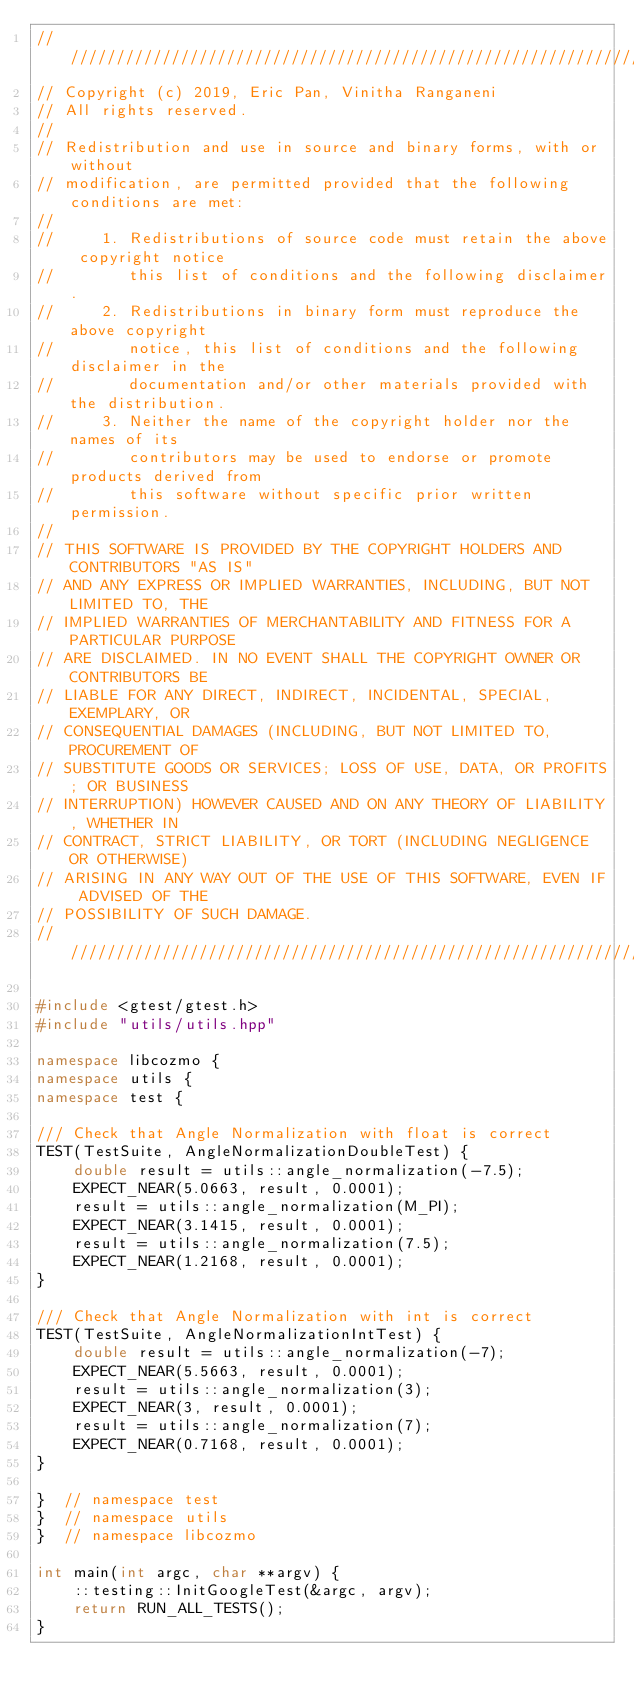Convert code to text. <code><loc_0><loc_0><loc_500><loc_500><_C++_>////////////////////////////////////////////////////////////////////////////////
// Copyright (c) 2019, Eric Pan, Vinitha Ranganeni
// All rights reserved.
//
// Redistribution and use in source and binary forms, with or without
// modification, are permitted provided that the following conditions are met:
//
//     1. Redistributions of source code must retain the above copyright notice
//        this list of conditions and the following disclaimer.
//     2. Redistributions in binary form must reproduce the above copyright
//        notice, this list of conditions and the following disclaimer in the
//        documentation and/or other materials provided with the distribution.
//     3. Neither the name of the copyright holder nor the names of its
//        contributors may be used to endorse or promote products derived from
//        this software without specific prior written permission.
//
// THIS SOFTWARE IS PROVIDED BY THE COPYRIGHT HOLDERS AND CONTRIBUTORS "AS IS"
// AND ANY EXPRESS OR IMPLIED WARRANTIES, INCLUDING, BUT NOT LIMITED TO, THE
// IMPLIED WARRANTIES OF MERCHANTABILITY AND FITNESS FOR A PARTICULAR PURPOSE
// ARE DISCLAIMED. IN NO EVENT SHALL THE COPYRIGHT OWNER OR CONTRIBUTORS BE
// LIABLE FOR ANY DIRECT, INDIRECT, INCIDENTAL, SPECIAL, EXEMPLARY, OR
// CONSEQUENTIAL DAMAGES (INCLUDING, BUT NOT LIMITED TO, PROCUREMENT OF
// SUBSTITUTE GOODS OR SERVICES; LOSS OF USE, DATA, OR PROFITS; OR BUSINESS
// INTERRUPTION) HOWEVER CAUSED AND ON ANY THEORY OF LIABILITY, WHETHER IN
// CONTRACT, STRICT LIABILITY, OR TORT (INCLUDING NEGLIGENCE OR OTHERWISE)
// ARISING IN ANY WAY OUT OF THE USE OF THIS SOFTWARE, EVEN IF ADVISED OF THE
// POSSIBILITY OF SUCH DAMAGE.
////////////////////////////////////////////////////////////////////////////////

#include <gtest/gtest.h>
#include "utils/utils.hpp"

namespace libcozmo {
namespace utils {
namespace test {

/// Check that Angle Normalization with float is correct
TEST(TestSuite, AngleNormalizationDoubleTest) {
    double result = utils::angle_normalization(-7.5);
    EXPECT_NEAR(5.0663, result, 0.0001);
    result = utils::angle_normalization(M_PI);
    EXPECT_NEAR(3.1415, result, 0.0001);
    result = utils::angle_normalization(7.5);
    EXPECT_NEAR(1.2168, result, 0.0001);
}

/// Check that Angle Normalization with int is correct
TEST(TestSuite, AngleNormalizationIntTest) {
    double result = utils::angle_normalization(-7);
    EXPECT_NEAR(5.5663, result, 0.0001);
    result = utils::angle_normalization(3);
    EXPECT_NEAR(3, result, 0.0001);
    result = utils::angle_normalization(7);
    EXPECT_NEAR(0.7168, result, 0.0001);
}

}  // namespace test
}  // namespace utils
}  // namespace libcozmo

int main(int argc, char **argv) {
    ::testing::InitGoogleTest(&argc, argv);
    return RUN_ALL_TESTS();
}
</code> 